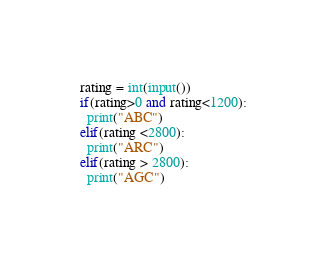<code> <loc_0><loc_0><loc_500><loc_500><_Python_>rating = int(input())
if(rating>0 and rating<1200):
  print("ABC")
elif(rating <2800):
  print("ARC")
elif(rating > 2800):
  print("AGC")</code> 